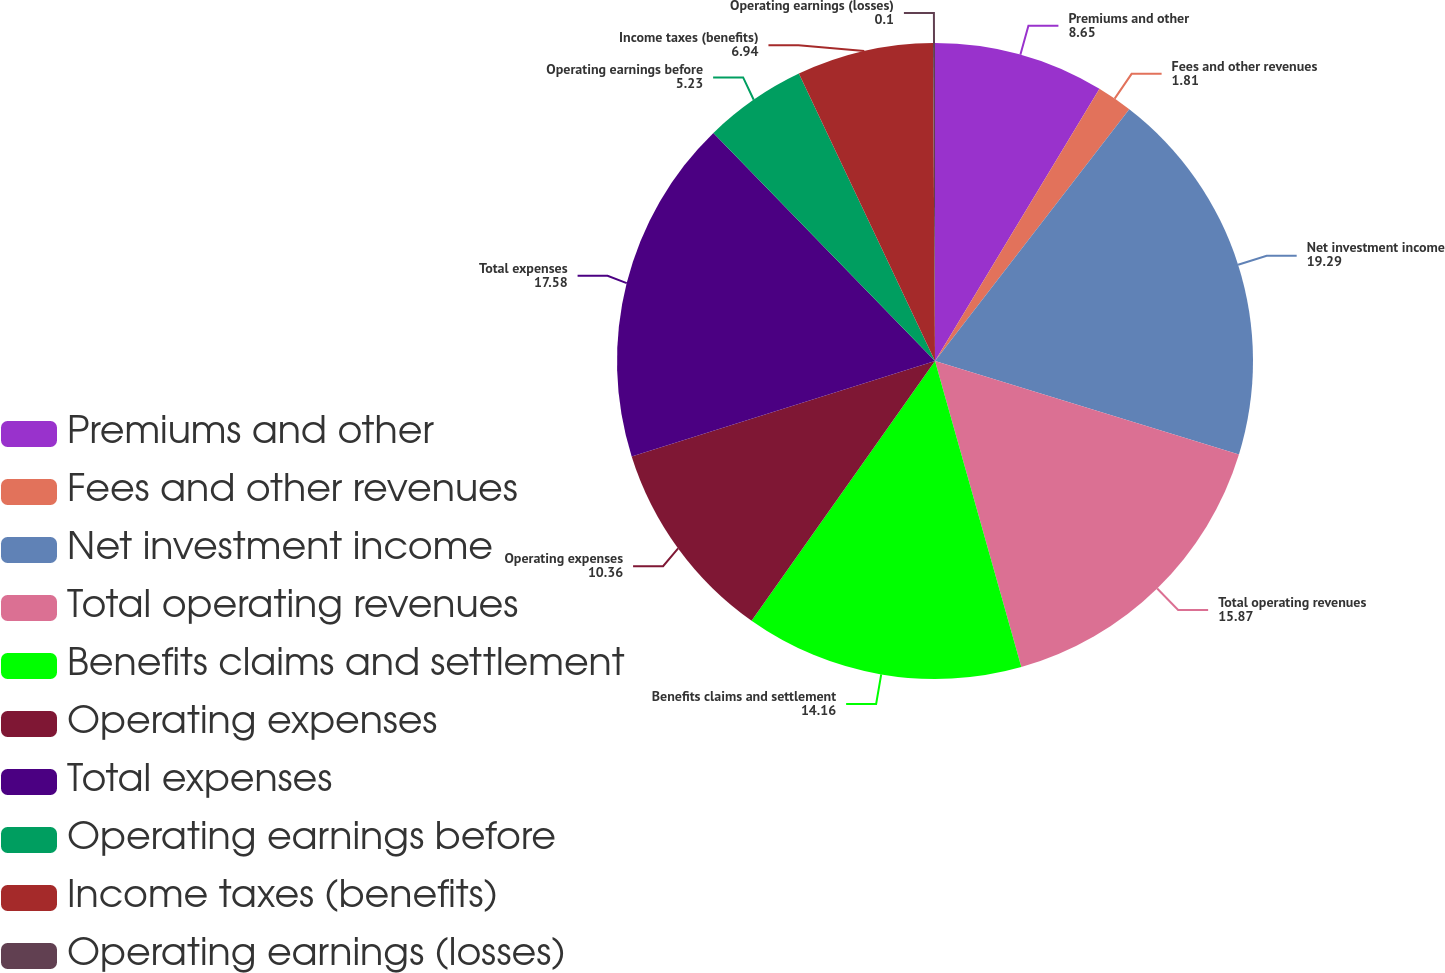Convert chart. <chart><loc_0><loc_0><loc_500><loc_500><pie_chart><fcel>Premiums and other<fcel>Fees and other revenues<fcel>Net investment income<fcel>Total operating revenues<fcel>Benefits claims and settlement<fcel>Operating expenses<fcel>Total expenses<fcel>Operating earnings before<fcel>Income taxes (benefits)<fcel>Operating earnings (losses)<nl><fcel>8.65%<fcel>1.81%<fcel>19.29%<fcel>15.87%<fcel>14.16%<fcel>10.36%<fcel>17.58%<fcel>5.23%<fcel>6.94%<fcel>0.1%<nl></chart> 